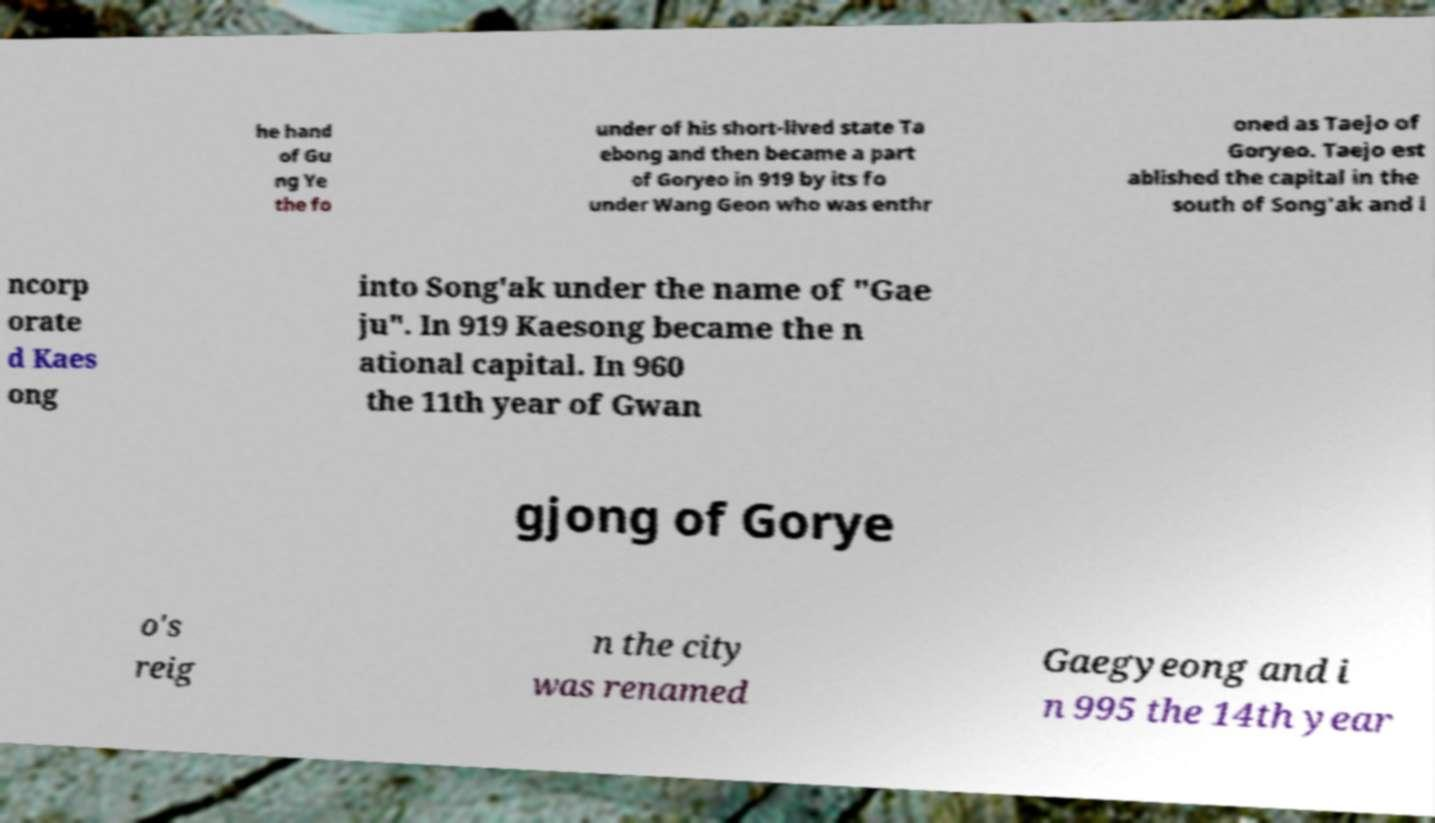Can you accurately transcribe the text from the provided image for me? he hand of Gu ng Ye the fo under of his short-lived state Ta ebong and then became a part of Goryeo in 919 by its fo under Wang Geon who was enthr oned as Taejo of Goryeo. Taejo est ablished the capital in the south of Song'ak and i ncorp orate d Kaes ong into Song'ak under the name of "Gae ju". In 919 Kaesong became the n ational capital. In 960 the 11th year of Gwan gjong of Gorye o's reig n the city was renamed Gaegyeong and i n 995 the 14th year 